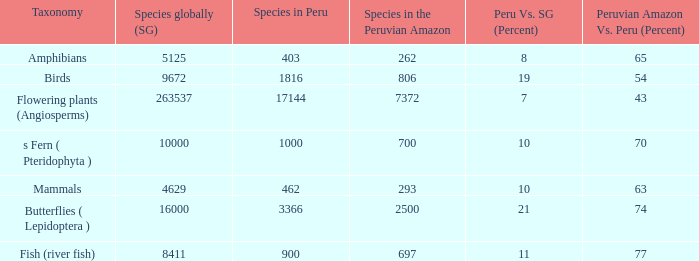Parse the full table. {'header': ['Taxonomy', 'Species globally (SG)', 'Species in Peru', 'Species in the Peruvian Amazon', 'Peru Vs. SG (Percent)', 'Peruvian Amazon Vs. Peru (Percent)'], 'rows': [['Amphibians', '5125', '403', '262', '8', '65'], ['Birds', '9672', '1816', '806', '19', '54'], ['Flowering plants (Angiosperms)', '263537', '17144', '7372', '7', '43'], ['s Fern ( Pteridophyta )', '10000', '1000', '700', '10', '70'], ['Mammals', '4629', '462', '293', '10', '63'], ['Butterflies ( Lepidoptera )', '16000', '3366', '2500', '21', '74'], ['Fish (river fish)', '8411', '900', '697', '11', '77']]} What's the total number of species in the peruvian amazon with 8411 species in the world  1.0. 